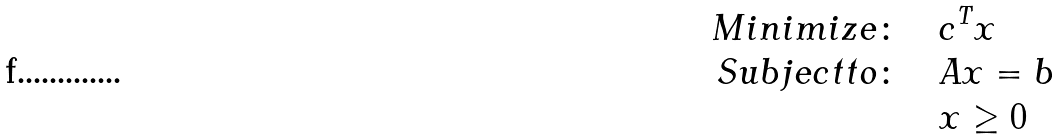<formula> <loc_0><loc_0><loc_500><loc_500>M i n i m i z e \colon \quad & c ^ { T } x \\ S u b j e c t t o \colon \quad & A x = b \\ & x \geq 0</formula> 